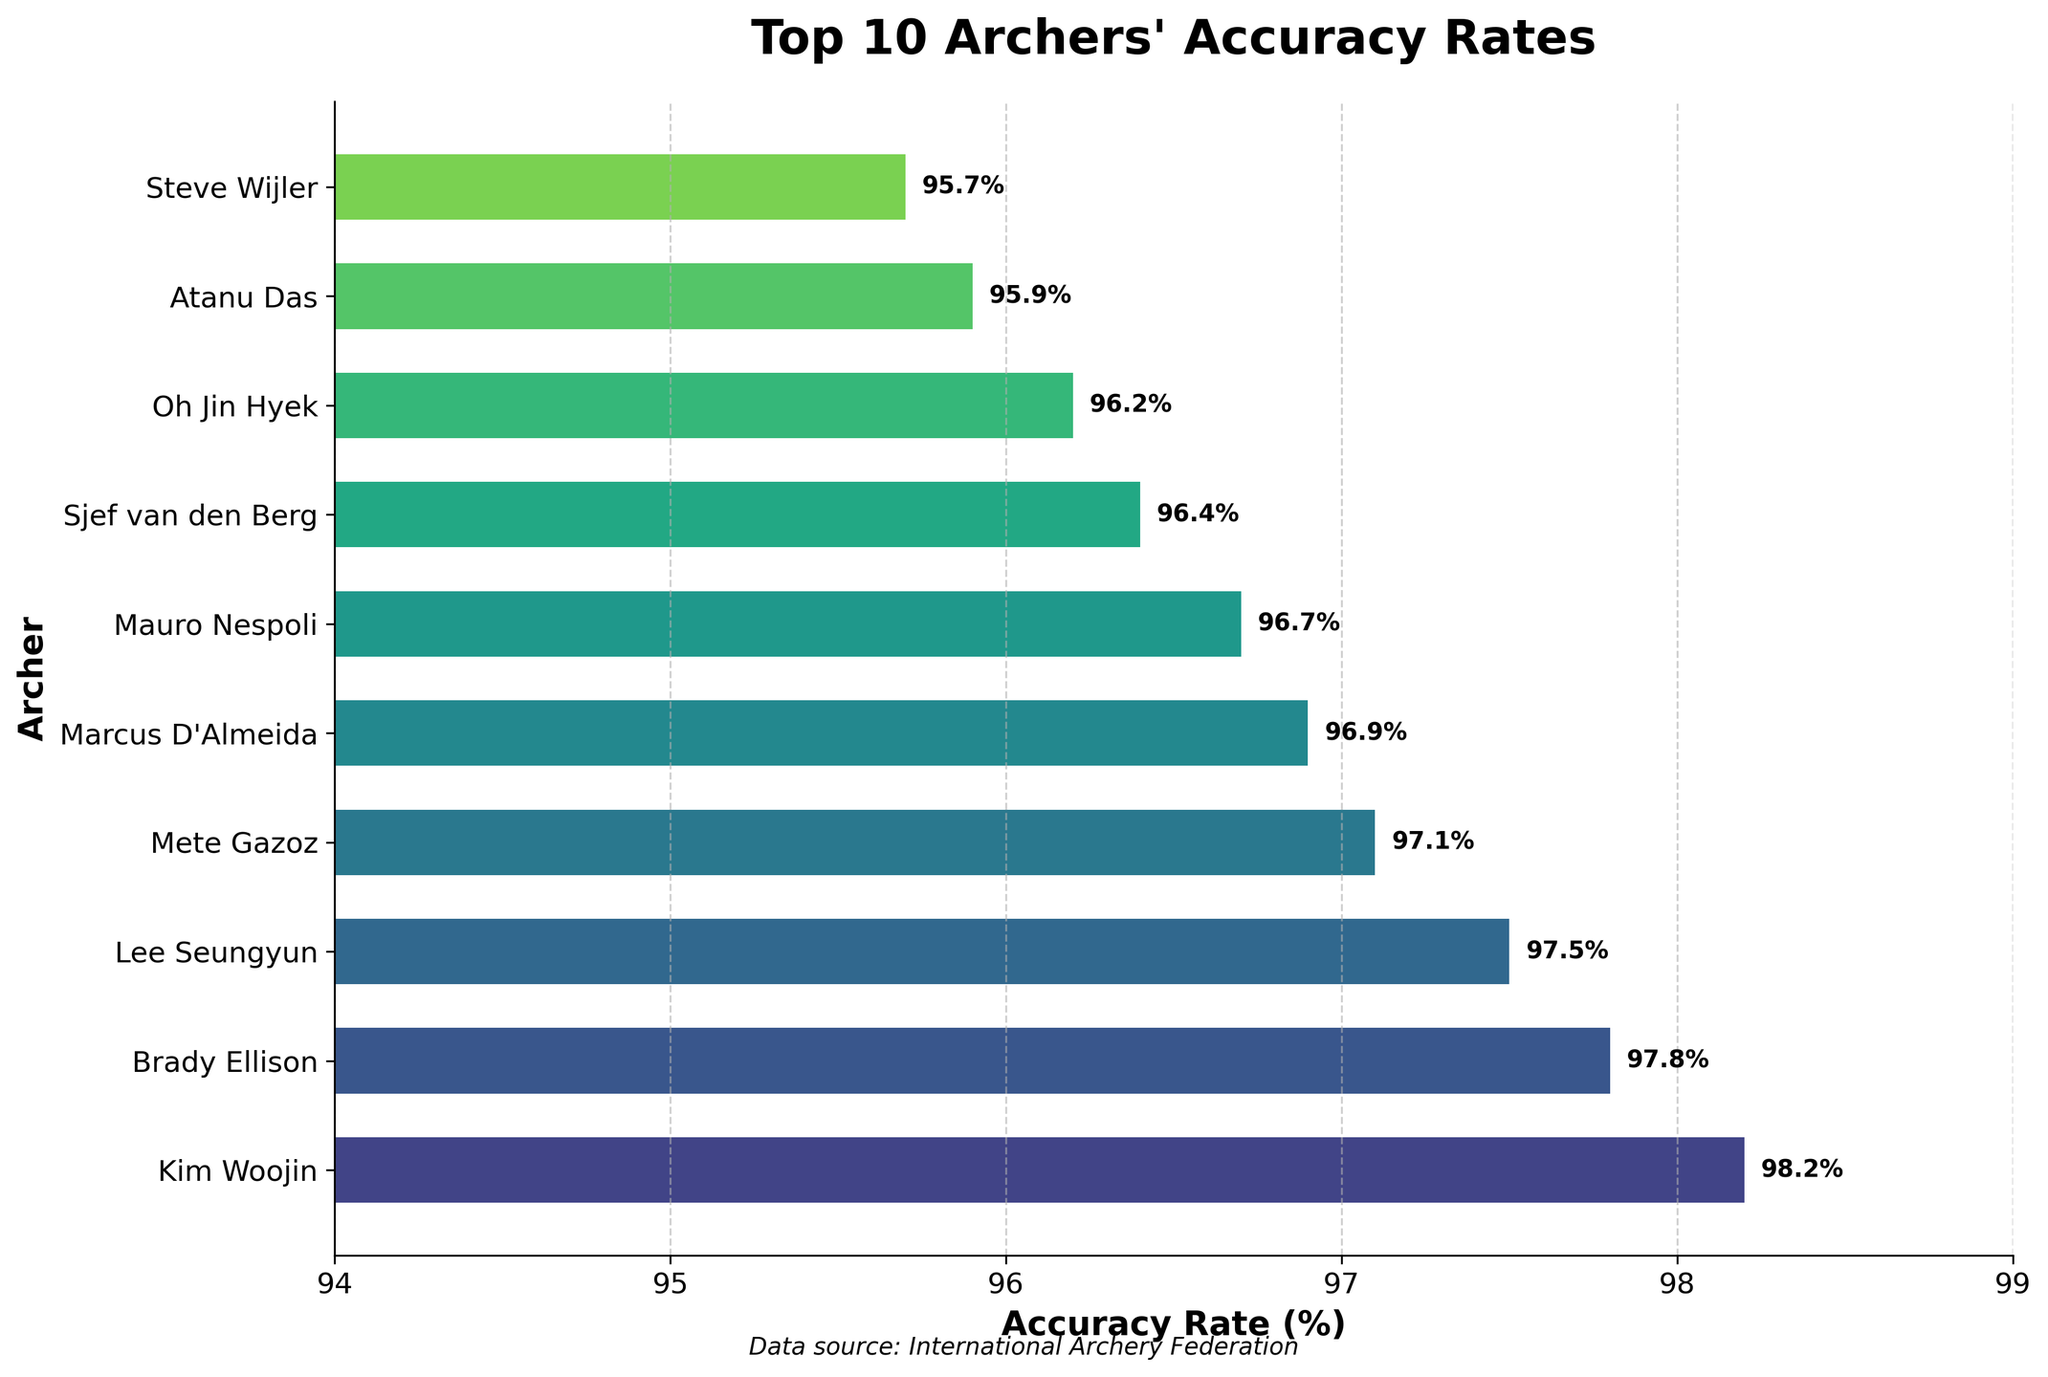Which archer has the highest accuracy rate? The figure shows that Kim Woojin has the highest accuracy rate at 98.2%. By observing where each bar ends, Kim Woojin's bar extends furthest to the right, indicating the highest value.
Answer: Kim Woojin What is the difference in accuracy rates between Kim Woojin and Sjef van den Berg? Kim Woojin's accuracy rate is 98.2%, and Sjef van den Berg's is 96.4%. Subtracting Sjef van den Berg's rate from Kim Woojin's (98.2% - 96.4%) gives the difference.
Answer: 1.8% Who has a higher accuracy rate, Lee Seungyun or Atanu Das? The bar length for Lee Seungyun ends at 97.5%, while Atanu Das's bar ends at 95.9%. By comparing these values, Lee Seungyun has a higher accuracy rate.
Answer: Lee Seungyun What is the sum of the accuracy rates for the top 3 archers? The top 3 archers are Kim Woojin (98.2%), Brady Ellison (97.8%), and Lee Seungyun (97.5%). Summing these values, 98.2 + 97.8 + 97.5, gives the total accuracy rate.
Answer: 293.5% What is the average accuracy rate of the top 10 archers? Sum the accuracy rates of the top 10 archers: 98.2 + 97.8 + 97.5 + 97.1 + 96.9 + 96.7 + 96.4 + 96.2 + 95.9 + 95.7, which equals 969.4. Dividing by 10 gives the average.
Answer: 96.94% Which archer is ranked 5th in terms of accuracy rate? The figure lists the archers in descending order of their accuracy rates, with the 5th position represented by Marcus D'Almeida with an accuracy rate of 96.9%.
Answer: Marcus D'Almeida How much higher is Brady Ellison’s accuracy rate compared to Wei Chun-Heng's, who is not in the top 10? Brady Ellison's accuracy rate is 97.8%, while Wei Chun-Heng's is 94.9%. Subtract Wei Chun-Heng's rate from Brady Ellison's (97.8% - 94.9%) to get the difference.
Answer: 2.9% What is the range of accuracy rates among the top 10 archers? The highest accuracy rate is 98.2% (Kim Woojin) and the lowest is 95.7% (Steve Wijler). Subtract the lowest from the highest (98.2% - 95.7%) to get the range.
Answer: 2.5% How many archers have an accuracy rate above 97%? The figure shows the accuracy rates, and counting the archers with rates higher than 97%: Kim Woojin, Brady Ellison, Lee Seungyun, Mete Gazoz, and Marcus D'Almeida makes 5 archers.
Answer: 5 What colors are used to represent the bars in the chart? The bars use a gradient of colors similar to those from a "viridis" color map, varying from green to blue. This can be visually identified by observing the gradient transition among the bars.
Answer: Green to blue 